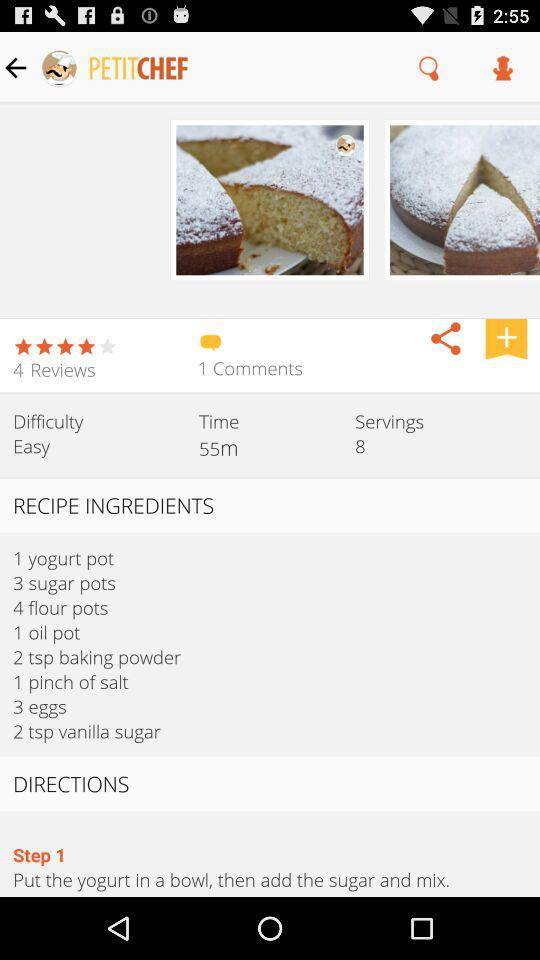How many servings are there? There are 8 servings. 